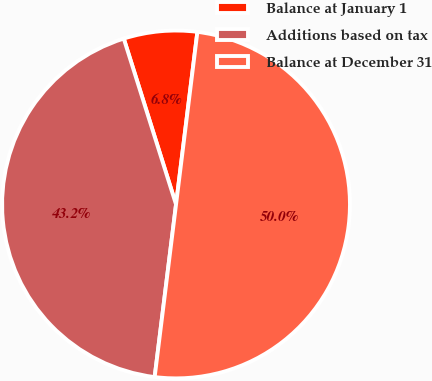Convert chart. <chart><loc_0><loc_0><loc_500><loc_500><pie_chart><fcel>Balance at January 1<fcel>Additions based on tax<fcel>Balance at December 31<nl><fcel>6.82%<fcel>43.18%<fcel>50.0%<nl></chart> 